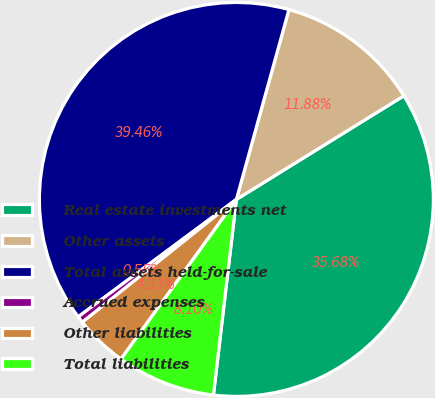Convert chart. <chart><loc_0><loc_0><loc_500><loc_500><pie_chart><fcel>Real estate investments net<fcel>Other assets<fcel>Total assets held-for-sale<fcel>Accrued expenses<fcel>Other liabilities<fcel>Total liabilities<nl><fcel>35.68%<fcel>11.88%<fcel>39.46%<fcel>0.55%<fcel>4.33%<fcel>8.1%<nl></chart> 